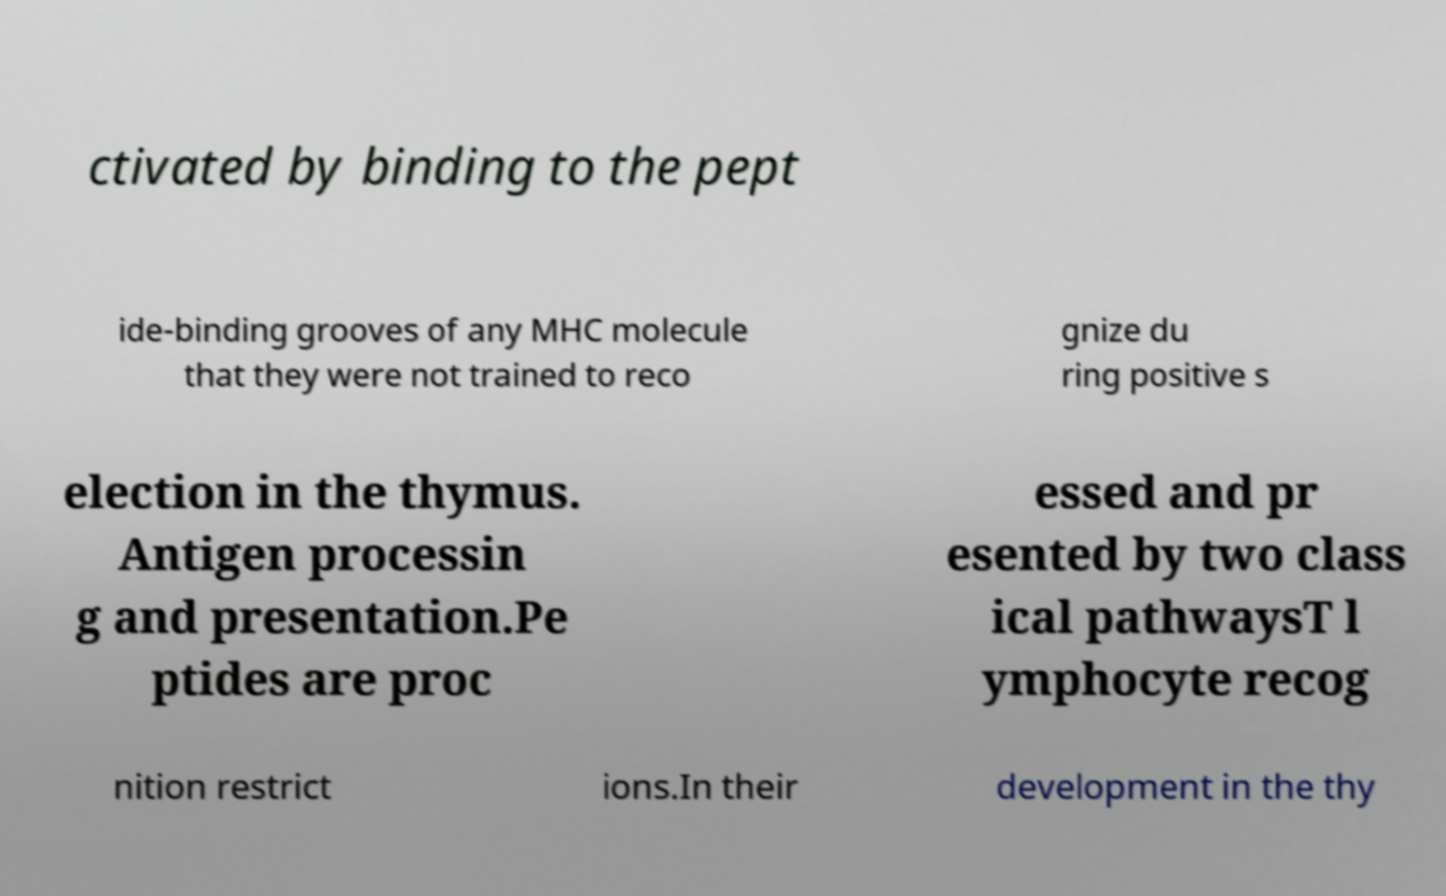Please read and relay the text visible in this image. What does it say? ctivated by binding to the pept ide-binding grooves of any MHC molecule that they were not trained to reco gnize du ring positive s election in the thymus. Antigen processin g and presentation.Pe ptides are proc essed and pr esented by two class ical pathwaysT l ymphocyte recog nition restrict ions.In their development in the thy 